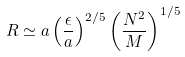<formula> <loc_0><loc_0><loc_500><loc_500>R \simeq a \left ( \frac { \epsilon } { a } \right ) ^ { 2 / 5 } \left ( \frac { N ^ { 2 } } { M } \right ) ^ { 1 / 5 }</formula> 